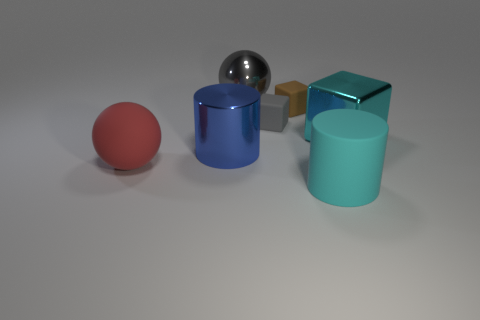If this image were part of a physics problem, what concept could it be used to illustrate? This image could be used to illustrate concepts of geometry, materials, and their properties, or even basic optics, given the different textures and reflective characteristics of the objects. If in motion, it could also demonstrate principles of momentum and collisions in a dynamic physics problem. 